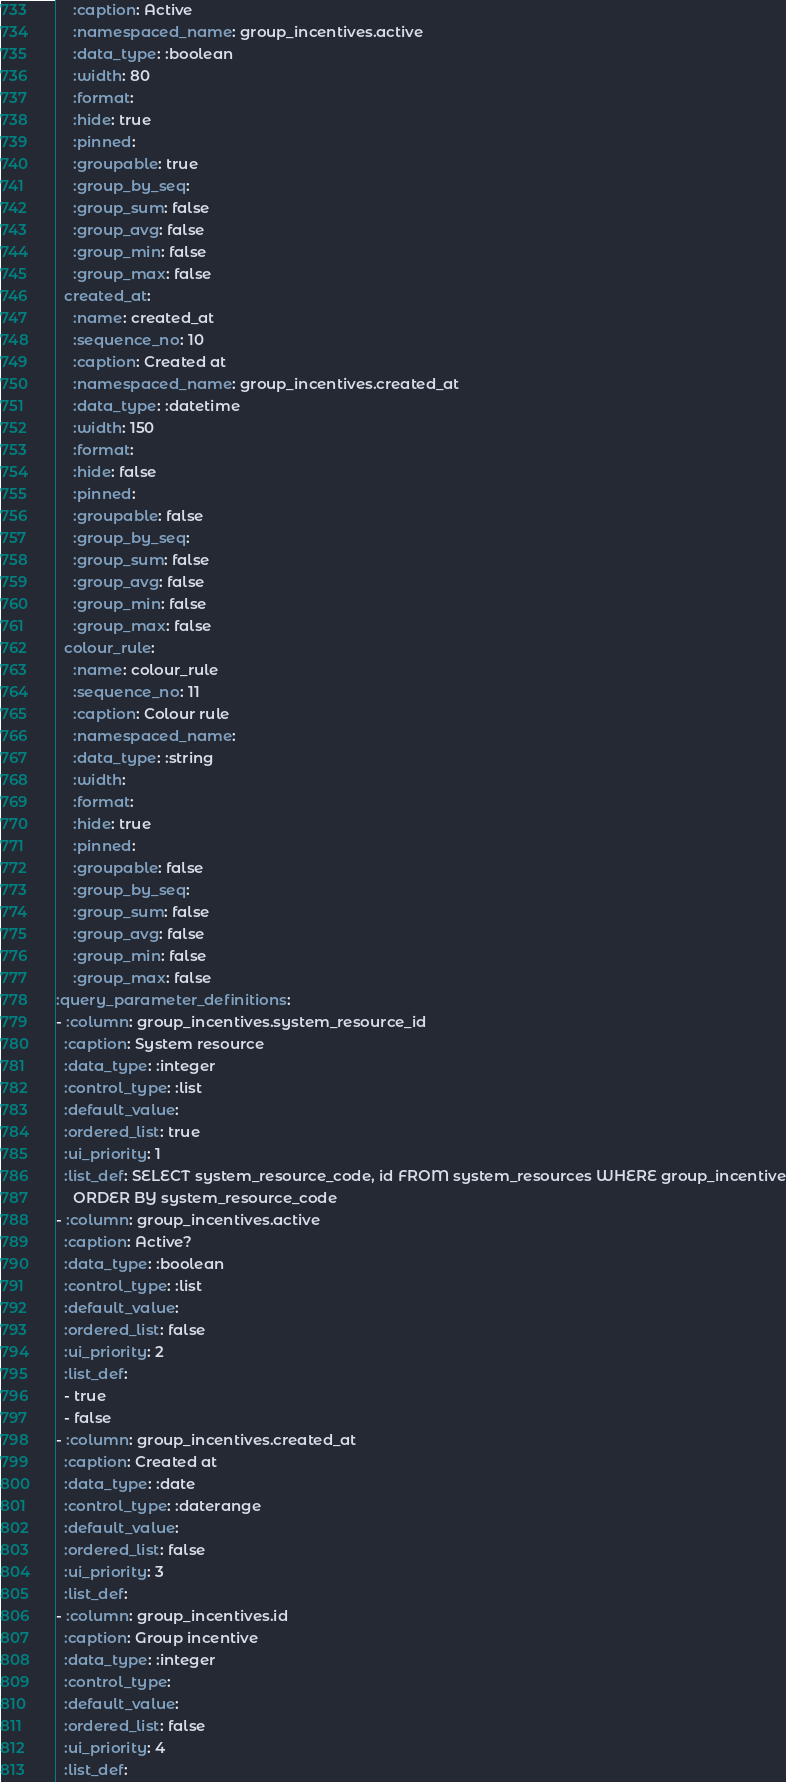<code> <loc_0><loc_0><loc_500><loc_500><_YAML_>    :caption: Active
    :namespaced_name: group_incentives.active
    :data_type: :boolean
    :width: 80
    :format: 
    :hide: true
    :pinned: 
    :groupable: true
    :group_by_seq: 
    :group_sum: false
    :group_avg: false
    :group_min: false
    :group_max: false
  created_at:
    :name: created_at
    :sequence_no: 10
    :caption: Created at
    :namespaced_name: group_incentives.created_at
    :data_type: :datetime
    :width: 150
    :format: 
    :hide: false
    :pinned: 
    :groupable: false
    :group_by_seq: 
    :group_sum: false
    :group_avg: false
    :group_min: false
    :group_max: false
  colour_rule:
    :name: colour_rule
    :sequence_no: 11
    :caption: Colour rule
    :namespaced_name: 
    :data_type: :string
    :width: 
    :format: 
    :hide: true
    :pinned: 
    :groupable: false
    :group_by_seq: 
    :group_sum: false
    :group_avg: false
    :group_min: false
    :group_max: false
:query_parameter_definitions:
- :column: group_incentives.system_resource_id
  :caption: System resource
  :data_type: :integer
  :control_type: :list
  :default_value: 
  :ordered_list: true
  :ui_priority: 1
  :list_def: SELECT system_resource_code, id FROM system_resources WHERE group_incentive
    ORDER BY system_resource_code
- :column: group_incentives.active
  :caption: Active?
  :data_type: :boolean
  :control_type: :list
  :default_value: 
  :ordered_list: false
  :ui_priority: 2
  :list_def:
  - true
  - false
- :column: group_incentives.created_at
  :caption: Created at
  :data_type: :date
  :control_type: :daterange
  :default_value: 
  :ordered_list: false
  :ui_priority: 3
  :list_def: 
- :column: group_incentives.id
  :caption: Group incentive
  :data_type: :integer
  :control_type: 
  :default_value: 
  :ordered_list: false
  :ui_priority: 4
  :list_def: 
</code> 